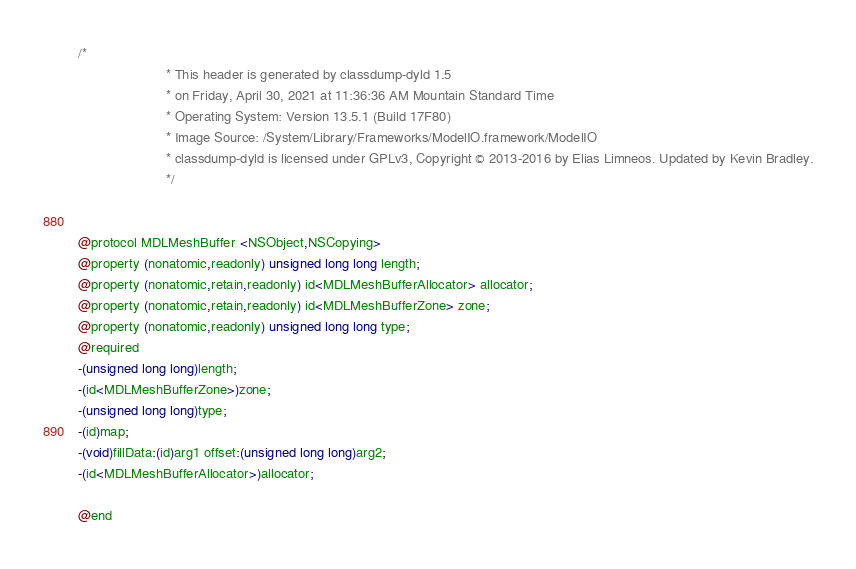<code> <loc_0><loc_0><loc_500><loc_500><_C_>/*
                       * This header is generated by classdump-dyld 1.5
                       * on Friday, April 30, 2021 at 11:36:36 AM Mountain Standard Time
                       * Operating System: Version 13.5.1 (Build 17F80)
                       * Image Source: /System/Library/Frameworks/ModelIO.framework/ModelIO
                       * classdump-dyld is licensed under GPLv3, Copyright © 2013-2016 by Elias Limneos. Updated by Kevin Bradley.
                       */


@protocol MDLMeshBuffer <NSObject,NSCopying>
@property (nonatomic,readonly) unsigned long long length; 
@property (nonatomic,retain,readonly) id<MDLMeshBufferAllocator> allocator; 
@property (nonatomic,retain,readonly) id<MDLMeshBufferZone> zone; 
@property (nonatomic,readonly) unsigned long long type; 
@required
-(unsigned long long)length;
-(id<MDLMeshBufferZone>)zone;
-(unsigned long long)type;
-(id)map;
-(void)fillData:(id)arg1 offset:(unsigned long long)arg2;
-(id<MDLMeshBufferAllocator>)allocator;

@end

</code> 